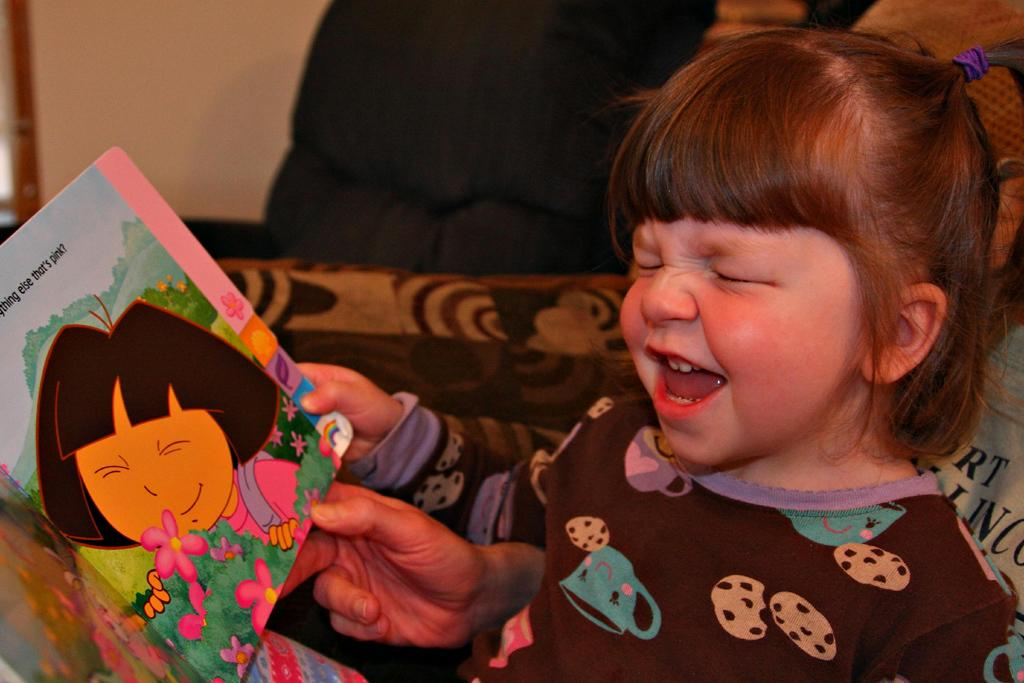What is the girl in the image doing? The girl is sitting in the image. What is the girl holding in the image? The girl is holding a book. What can be seen in the background of the image? There is a wall visible in the background of the image. What type of pie is the girl eating in the image? There is no pie present in the image; the girl is holding a book. 